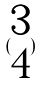<formula> <loc_0><loc_0><loc_500><loc_500>( \begin{matrix} 3 \\ 4 \end{matrix} )</formula> 